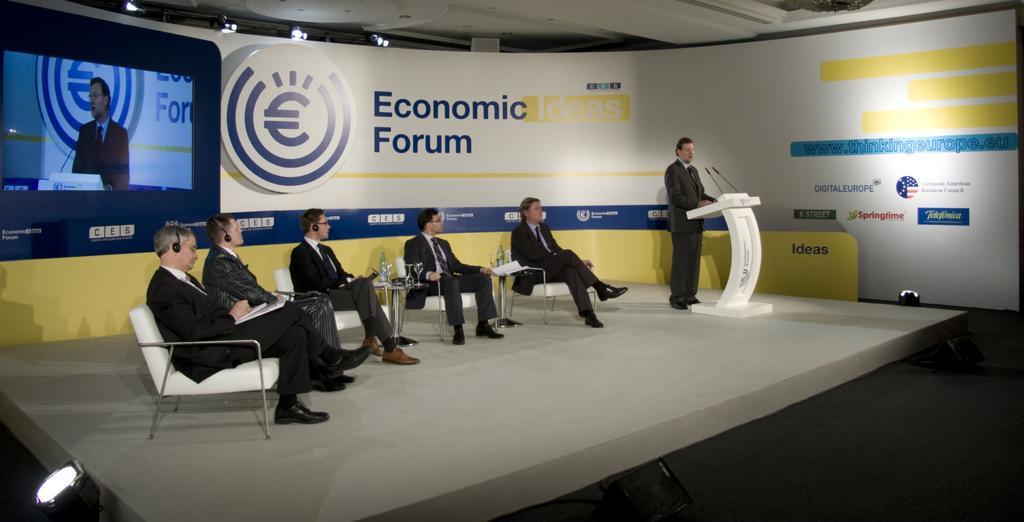How would you summarize this image in a sentence or two? In this image there are people sitting on chairs and a man standing near a podium, in the background there is a wall, for that wall there is some text and there is a screen, at the top there is a ceiling and lights. 